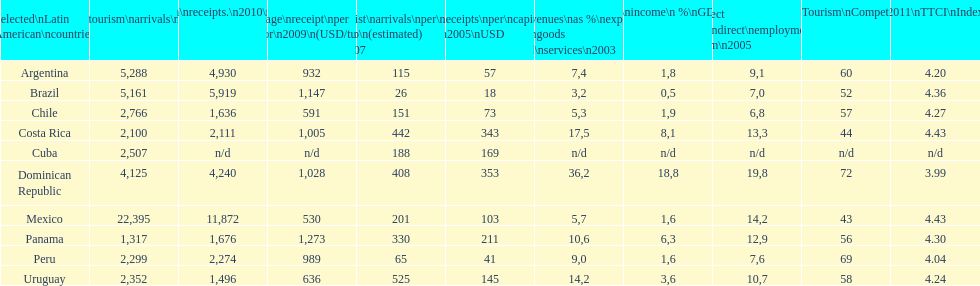What was the position of brazil in the list of countries with average income per tourist in 2009? 1,147. 